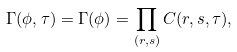<formula> <loc_0><loc_0><loc_500><loc_500>\Gamma ( \phi , \tau ) = \Gamma ( \phi ) = \prod _ { ( r , s ) } C ( r , s , \tau ) ,</formula> 